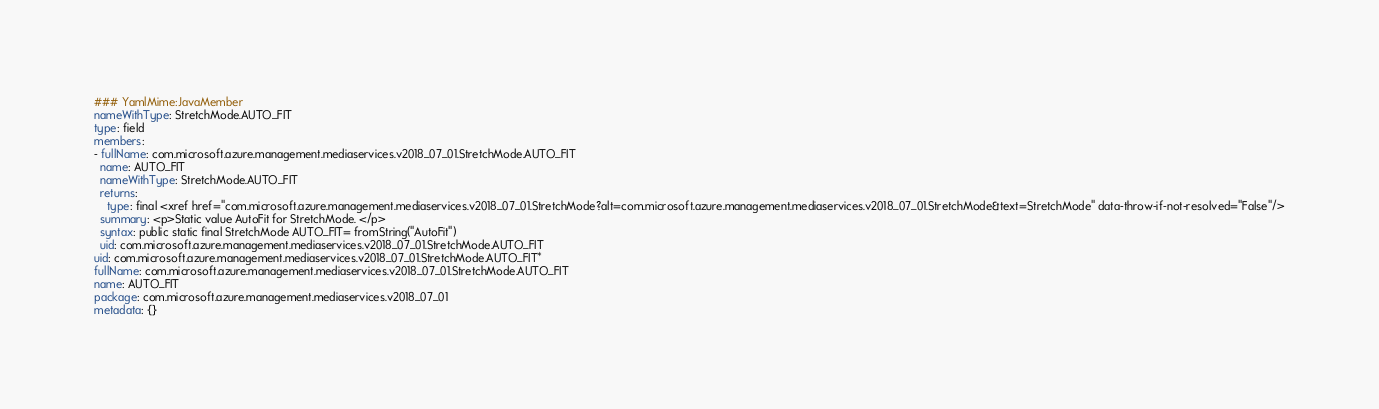<code> <loc_0><loc_0><loc_500><loc_500><_YAML_>### YamlMime:JavaMember
nameWithType: StretchMode.AUTO_FIT
type: field
members:
- fullName: com.microsoft.azure.management.mediaservices.v2018_07_01.StretchMode.AUTO_FIT
  name: AUTO_FIT
  nameWithType: StretchMode.AUTO_FIT
  returns:
    type: final <xref href="com.microsoft.azure.management.mediaservices.v2018_07_01.StretchMode?alt=com.microsoft.azure.management.mediaservices.v2018_07_01.StretchMode&text=StretchMode" data-throw-if-not-resolved="False"/>
  summary: <p>Static value AutoFit for StretchMode. </p>
  syntax: public static final StretchMode AUTO_FIT= fromString("AutoFit")
  uid: com.microsoft.azure.management.mediaservices.v2018_07_01.StretchMode.AUTO_FIT
uid: com.microsoft.azure.management.mediaservices.v2018_07_01.StretchMode.AUTO_FIT*
fullName: com.microsoft.azure.management.mediaservices.v2018_07_01.StretchMode.AUTO_FIT
name: AUTO_FIT
package: com.microsoft.azure.management.mediaservices.v2018_07_01
metadata: {}
</code> 